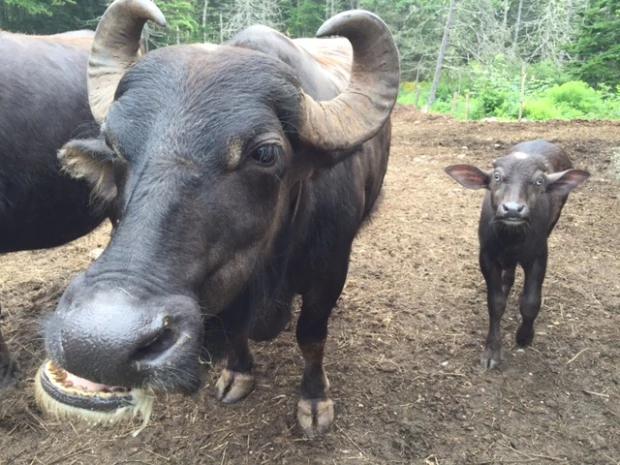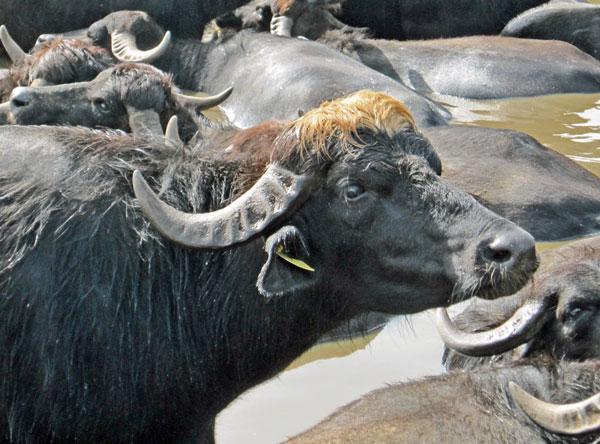The first image is the image on the left, the second image is the image on the right. For the images shown, is this caption "The foreground of each image contains water buffalo who look directly forward, and one image contains a single water buffalo in the foreground." true? Answer yes or no. No. The first image is the image on the left, the second image is the image on the right. Examine the images to the left and right. Is the description "The animals in the left image are next to a man made structure." accurate? Answer yes or no. No. 